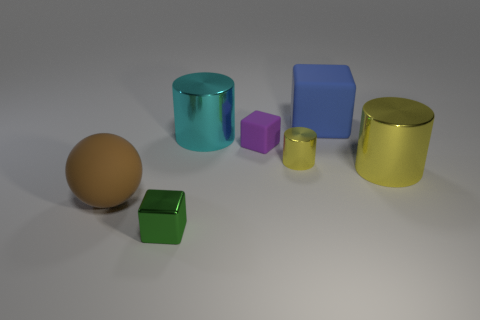What number of blue matte blocks are the same size as the green metallic object?
Your answer should be very brief. 0. Does the cube that is in front of the purple block have the same size as the matte object to the left of the green shiny object?
Offer a very short reply. No. What number of objects are either blue things or tiny shiny things behind the rubber sphere?
Keep it short and to the point. 2. What color is the small matte thing?
Provide a short and direct response. Purple. There is a big cylinder on the left side of the big cylinder right of the tiny cube that is behind the large sphere; what is its material?
Offer a terse response. Metal. What size is the green object that is made of the same material as the small yellow cylinder?
Keep it short and to the point. Small. Is there a big metallic cylinder of the same color as the tiny metallic cylinder?
Your response must be concise. Yes. There is a brown rubber object; is its size the same as the rubber object that is behind the large cyan cylinder?
Give a very brief answer. Yes. There is a cylinder to the left of the yellow thing to the left of the blue rubber cube; how many tiny green shiny objects are on the right side of it?
Ensure brevity in your answer.  0. Are there any big yellow metallic objects left of the big cyan metal cylinder?
Give a very brief answer. No. 